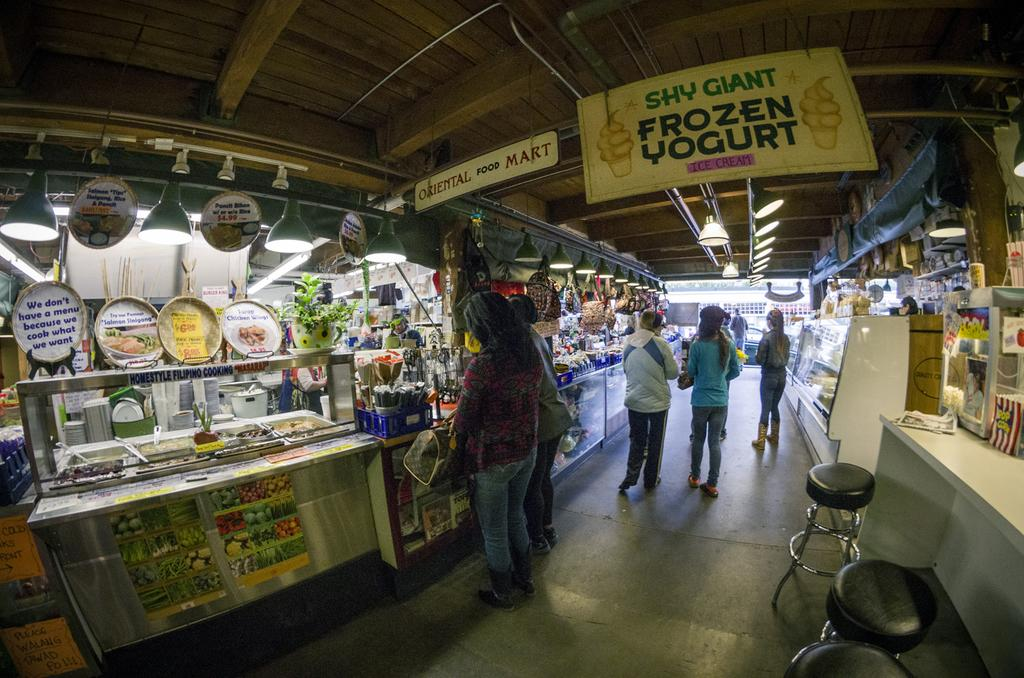<image>
Describe the image concisely. the market advertises frozen yogurt from a ceiling banner 